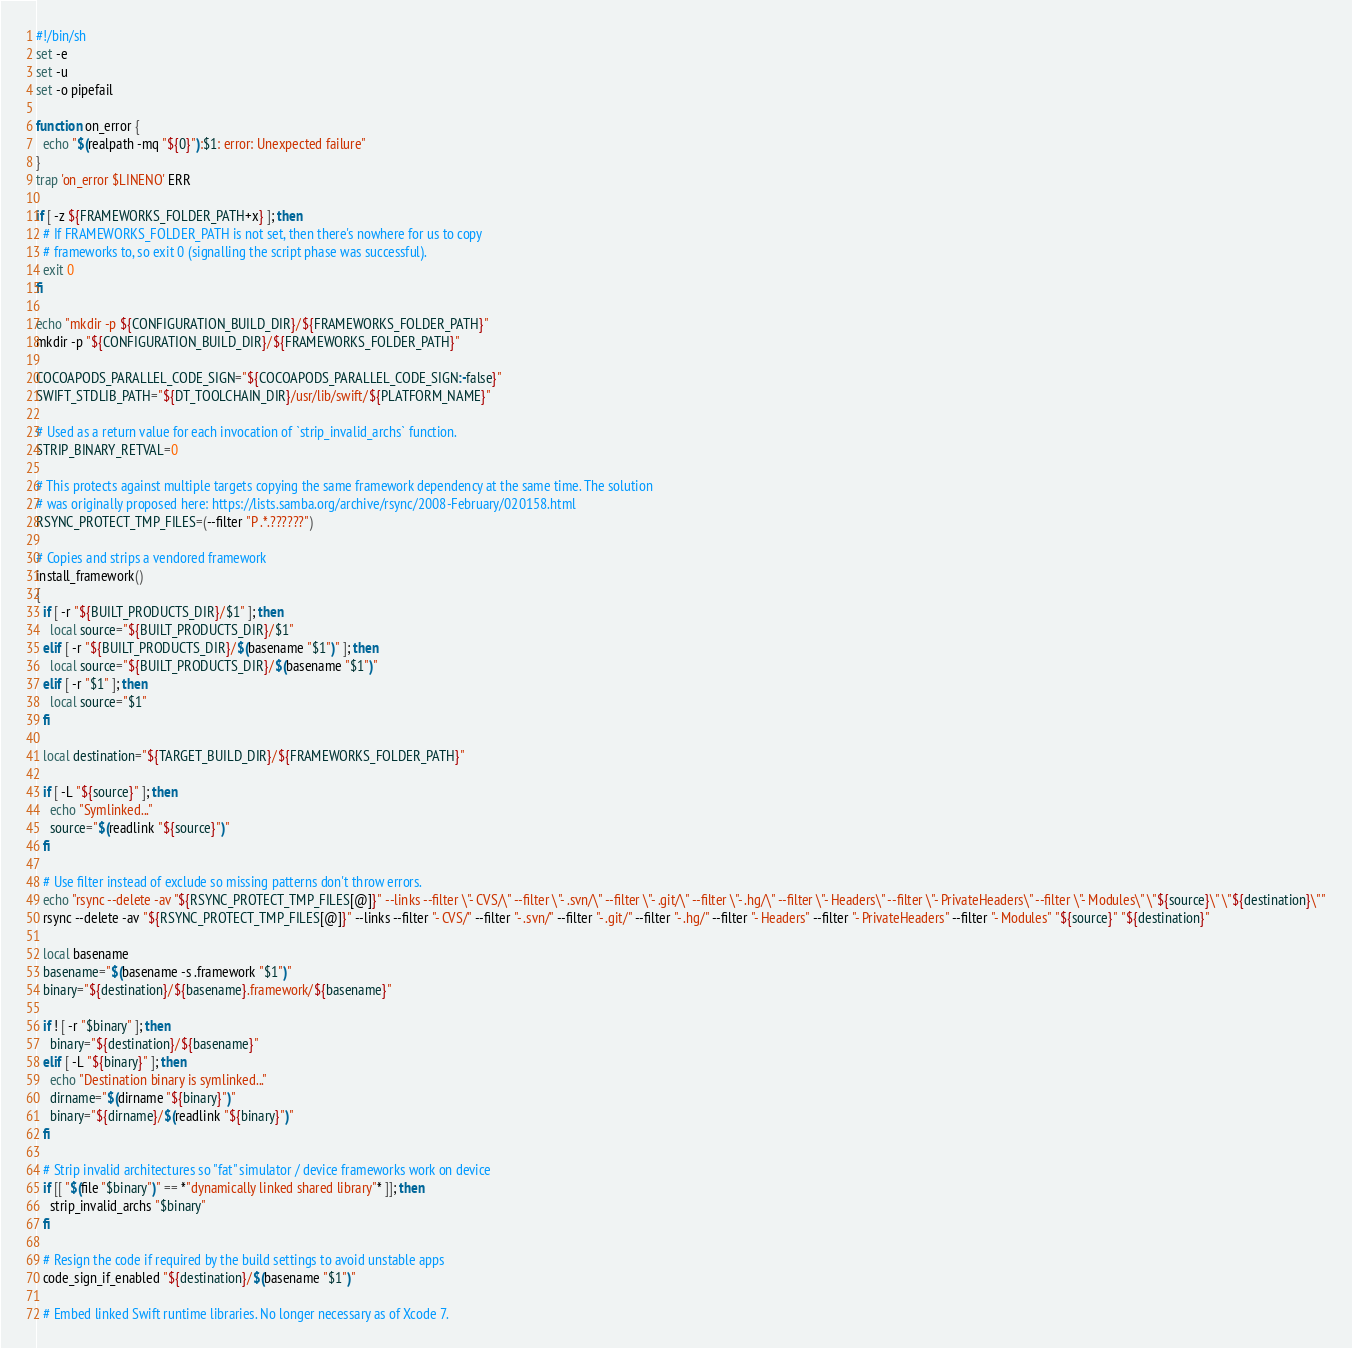<code> <loc_0><loc_0><loc_500><loc_500><_Bash_>#!/bin/sh
set -e
set -u
set -o pipefail

function on_error {
  echo "$(realpath -mq "${0}"):$1: error: Unexpected failure"
}
trap 'on_error $LINENO' ERR

if [ -z ${FRAMEWORKS_FOLDER_PATH+x} ]; then
  # If FRAMEWORKS_FOLDER_PATH is not set, then there's nowhere for us to copy
  # frameworks to, so exit 0 (signalling the script phase was successful).
  exit 0
fi

echo "mkdir -p ${CONFIGURATION_BUILD_DIR}/${FRAMEWORKS_FOLDER_PATH}"
mkdir -p "${CONFIGURATION_BUILD_DIR}/${FRAMEWORKS_FOLDER_PATH}"

COCOAPODS_PARALLEL_CODE_SIGN="${COCOAPODS_PARALLEL_CODE_SIGN:-false}"
SWIFT_STDLIB_PATH="${DT_TOOLCHAIN_DIR}/usr/lib/swift/${PLATFORM_NAME}"

# Used as a return value for each invocation of `strip_invalid_archs` function.
STRIP_BINARY_RETVAL=0

# This protects against multiple targets copying the same framework dependency at the same time. The solution
# was originally proposed here: https://lists.samba.org/archive/rsync/2008-February/020158.html
RSYNC_PROTECT_TMP_FILES=(--filter "P .*.??????")

# Copies and strips a vendored framework
install_framework()
{
  if [ -r "${BUILT_PRODUCTS_DIR}/$1" ]; then
    local source="${BUILT_PRODUCTS_DIR}/$1"
  elif [ -r "${BUILT_PRODUCTS_DIR}/$(basename "$1")" ]; then
    local source="${BUILT_PRODUCTS_DIR}/$(basename "$1")"
  elif [ -r "$1" ]; then
    local source="$1"
  fi

  local destination="${TARGET_BUILD_DIR}/${FRAMEWORKS_FOLDER_PATH}"

  if [ -L "${source}" ]; then
    echo "Symlinked..."
    source="$(readlink "${source}")"
  fi

  # Use filter instead of exclude so missing patterns don't throw errors.
  echo "rsync --delete -av "${RSYNC_PROTECT_TMP_FILES[@]}" --links --filter \"- CVS/\" --filter \"- .svn/\" --filter \"- .git/\" --filter \"- .hg/\" --filter \"- Headers\" --filter \"- PrivateHeaders\" --filter \"- Modules\" \"${source}\" \"${destination}\""
  rsync --delete -av "${RSYNC_PROTECT_TMP_FILES[@]}" --links --filter "- CVS/" --filter "- .svn/" --filter "- .git/" --filter "- .hg/" --filter "- Headers" --filter "- PrivateHeaders" --filter "- Modules" "${source}" "${destination}"

  local basename
  basename="$(basename -s .framework "$1")"
  binary="${destination}/${basename}.framework/${basename}"

  if ! [ -r "$binary" ]; then
    binary="${destination}/${basename}"
  elif [ -L "${binary}" ]; then
    echo "Destination binary is symlinked..."
    dirname="$(dirname "${binary}")"
    binary="${dirname}/$(readlink "${binary}")"
  fi

  # Strip invalid architectures so "fat" simulator / device frameworks work on device
  if [[ "$(file "$binary")" == *"dynamically linked shared library"* ]]; then
    strip_invalid_archs "$binary"
  fi

  # Resign the code if required by the build settings to avoid unstable apps
  code_sign_if_enabled "${destination}/$(basename "$1")"

  # Embed linked Swift runtime libraries. No longer necessary as of Xcode 7.</code> 